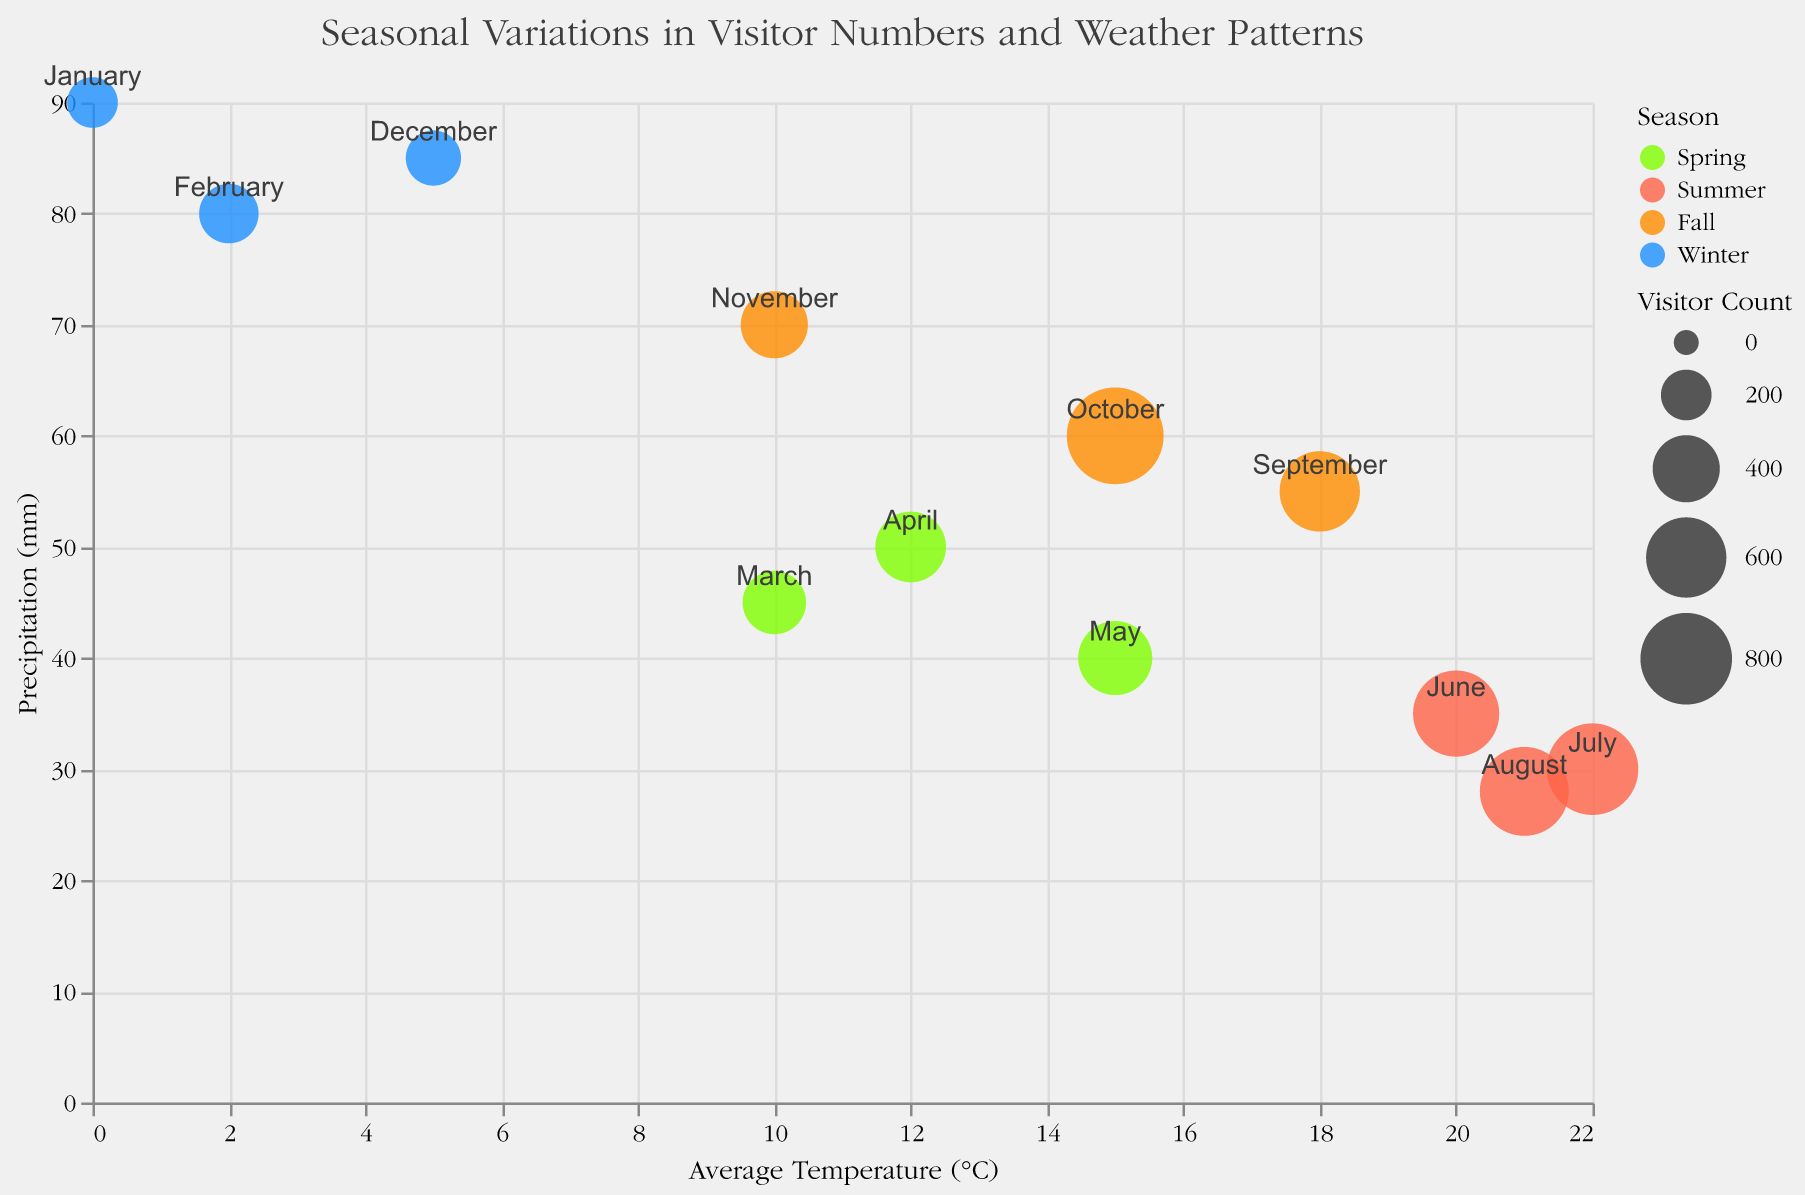What is the season with the highest visitor count in the figure? Identify the circle with the largest size and check the legend for its color indicating the season. This circle is in October, Fall season.
Answer: Fall Which event in the Winter season has the lowest visitor count? Look for circles that are colored in Winter's color, then identify the smallest circle among them, which is in January.
Answer: Ghost Stories by the Fire Do higher precipitation levels seem to correspond with lower visitor counts? Observe the overall trend: higher precipitation levels (y-axis) tend to have circles of smaller sizes, indicating lower visitor counts.
Answer: Yes What month has the highest number of visitors, and how does its average temperature compare to the temperature in November? The largest circle, indicating the highest visitor count, is in October. October's temperature is 15°C, and November's is 10°C.
Answer: October, higher How does the average temperature in June compare to the average temperature in December? Compare the x-axis values for the months of June and December (20°C for June, 5°C for December).
Answer: June is higher What event corresponds to the point in the figure with 12°C and 50mm of precipitation? Locate the circle at x=12 and y=50 on the axes. The tooltip shows this data point corresponds to the "Haunted Town Tour" event.
Answer: Haunted Town Tour Which season has the most variation in visitor numbers? Identify the season with the widest range of circle sizes. Winter has the smallest and largest circles, indicating high variation in visitor numbers.
Answer: Winter Does the coolest month of the year have one of the highest or lowest visitor counts? The coolest month is January (0°C). January's visitor count is 200, which is among the lowest.
Answer: Lowest Which event in the Winter season has the highest number of visitors? Look at circles colored for Winter and find the largest circle within that group. February's circle is largest among Winter months.
Answer: Mysterious Night Walk What is the range of average temperatures in the Spring season? Identify Spring season circles by color, find the lowest and highest x-axis values for these circles (March 10°C, May 15°C). The range is 10°C to 15°C.
Answer: 10°C to 15°C 